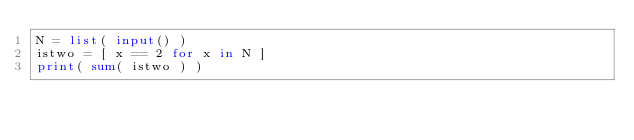Convert code to text. <code><loc_0><loc_0><loc_500><loc_500><_Python_>N = list( input() )
istwo = [ x == 2 for x in N ]
print( sum( istwo ) )
</code> 